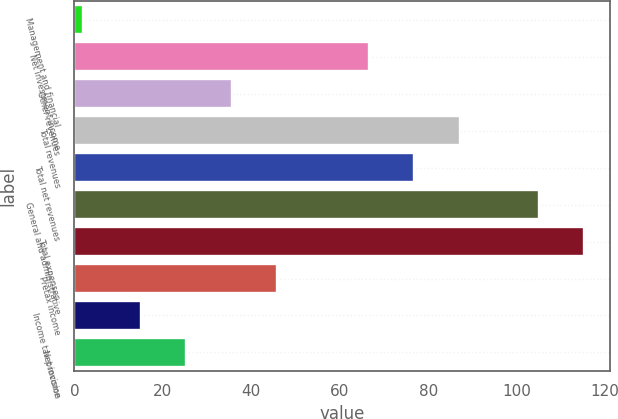Convert chart. <chart><loc_0><loc_0><loc_500><loc_500><bar_chart><fcel>Management and financial<fcel>Net investment income<fcel>Other revenues<fcel>Total revenues<fcel>Total net revenues<fcel>General and administrative<fcel>Total expenses<fcel>Pretax income<fcel>Income tax provision<fcel>Net income<nl><fcel>2<fcel>66.5<fcel>35.6<fcel>87.1<fcel>76.8<fcel>105<fcel>115.3<fcel>45.9<fcel>15<fcel>25.3<nl></chart> 